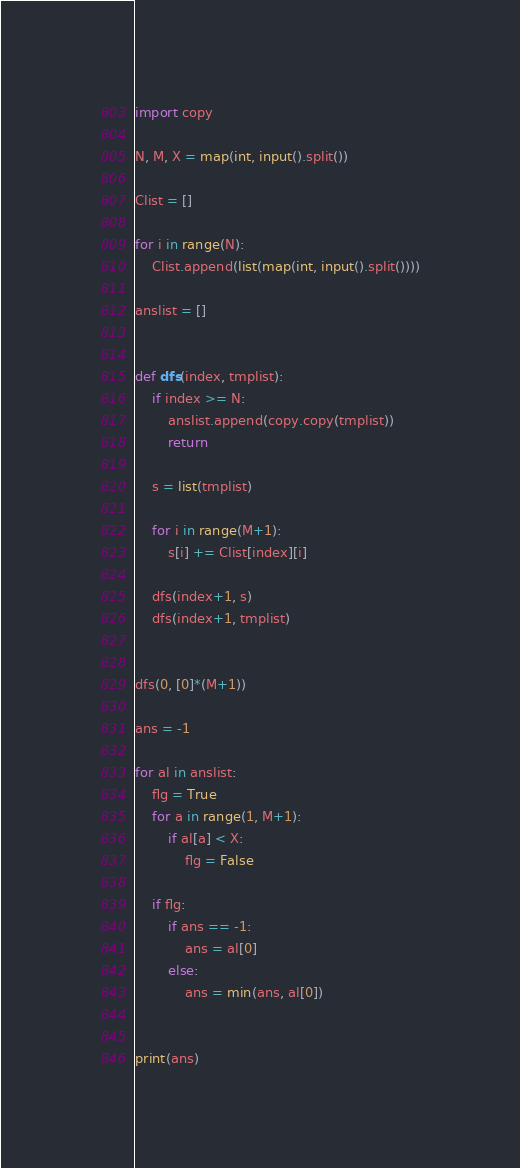<code> <loc_0><loc_0><loc_500><loc_500><_Python_>import copy

N, M, X = map(int, input().split())

Clist = []

for i in range(N):
    Clist.append(list(map(int, input().split())))

anslist = []


def dfs(index, tmplist):
    if index >= N:
        anslist.append(copy.copy(tmplist))
        return

    s = list(tmplist)

    for i in range(M+1):
        s[i] += Clist[index][i]

    dfs(index+1, s)
    dfs(index+1, tmplist)


dfs(0, [0]*(M+1))

ans = -1

for al in anslist:
    flg = True
    for a in range(1, M+1):
        if al[a] < X:
            flg = False

    if flg:
        if ans == -1:
            ans = al[0]
        else:
            ans = min(ans, al[0])


print(ans)
</code> 